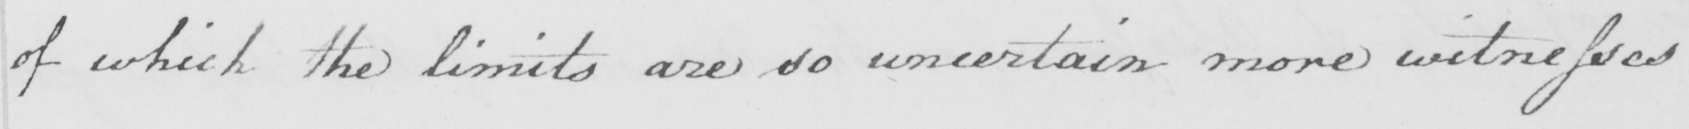Please provide the text content of this handwritten line. of which the limits are so uncertain more witnesses 